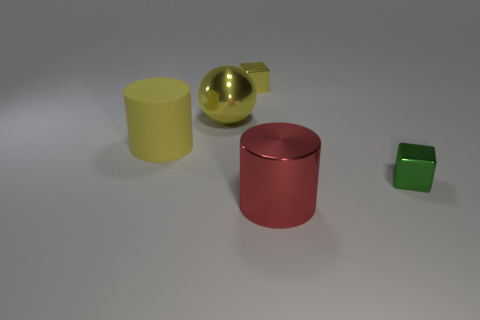Add 5 green blocks. How many objects exist? 10 Subtract all blocks. How many objects are left? 3 Subtract all small rubber things. Subtract all large objects. How many objects are left? 2 Add 2 small green metallic objects. How many small green metallic objects are left? 3 Add 1 large cylinders. How many large cylinders exist? 3 Subtract 0 gray spheres. How many objects are left? 5 